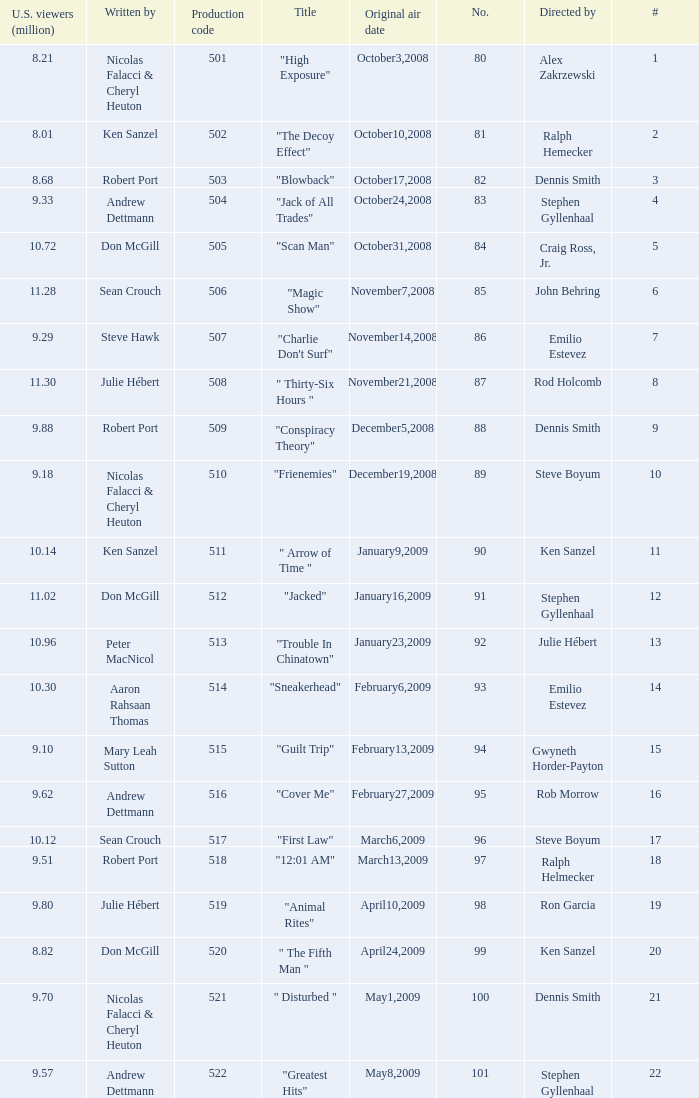What episode had 10.14 million viewers (U.S.)? 11.0. 